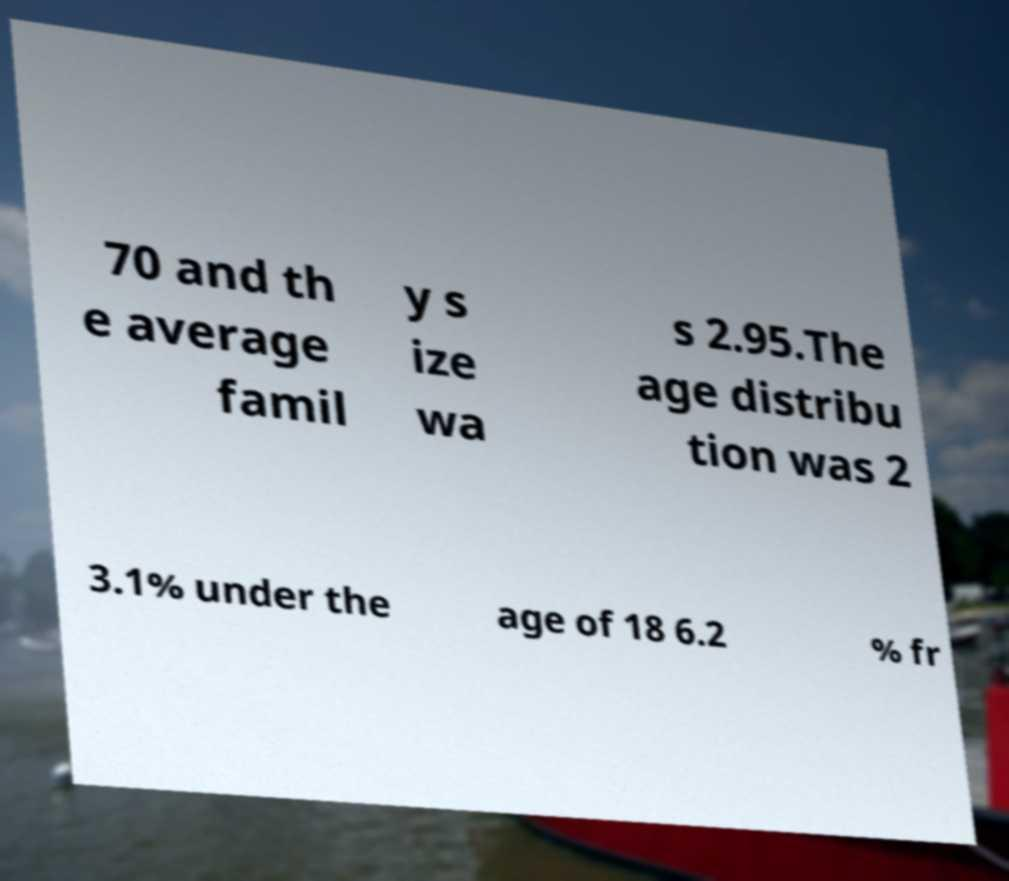For documentation purposes, I need the text within this image transcribed. Could you provide that? 70 and th e average famil y s ize wa s 2.95.The age distribu tion was 2 3.1% under the age of 18 6.2 % fr 